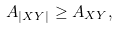Convert formula to latex. <formula><loc_0><loc_0><loc_500><loc_500>A _ { | X Y | } \geq A _ { X Y } ,</formula> 